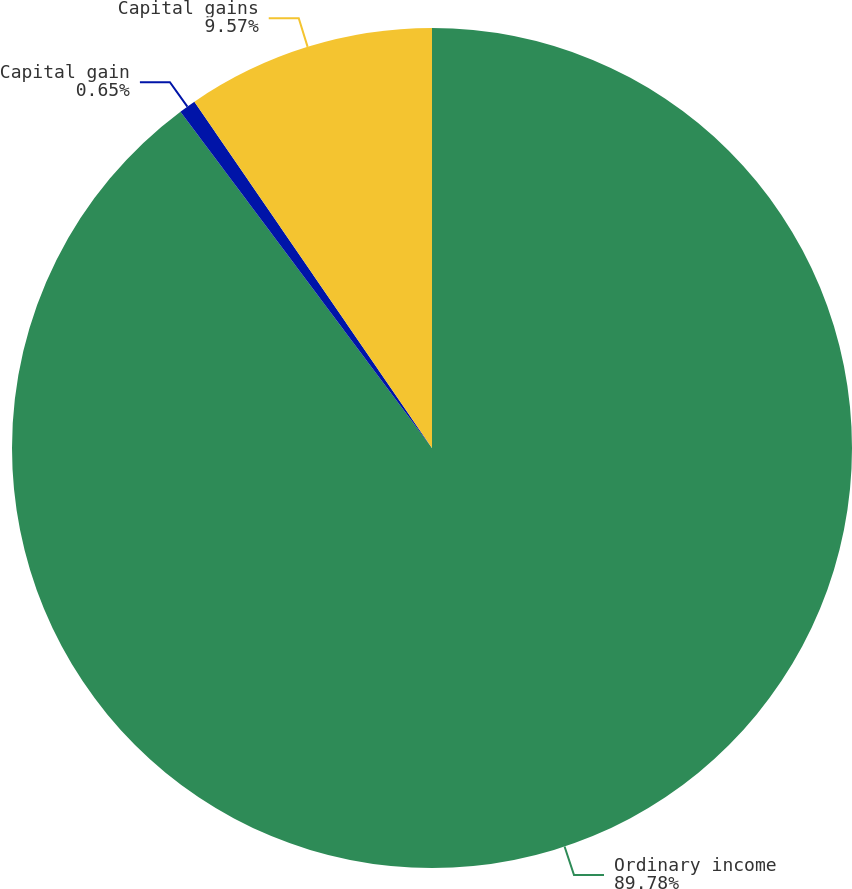Convert chart. <chart><loc_0><loc_0><loc_500><loc_500><pie_chart><fcel>Ordinary income<fcel>Capital gain<fcel>Capital gains<nl><fcel>89.78%<fcel>0.65%<fcel>9.57%<nl></chart> 